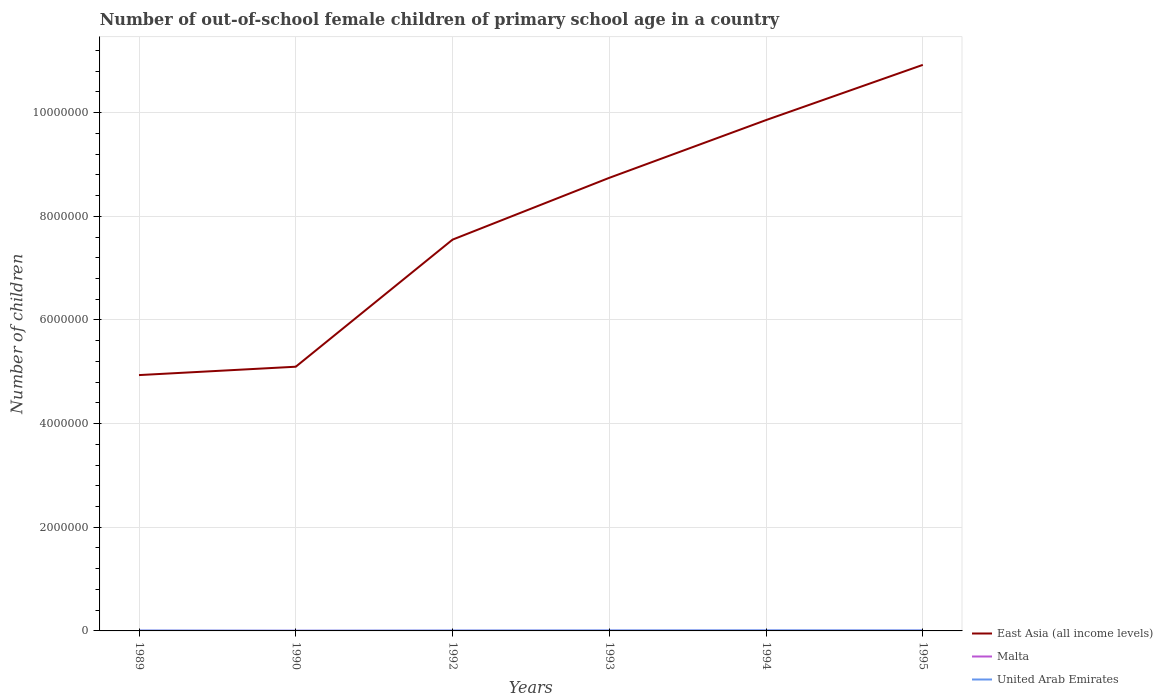Does the line corresponding to Malta intersect with the line corresponding to United Arab Emirates?
Keep it short and to the point. No. Across all years, what is the maximum number of out-of-school female children in Malta?
Provide a short and direct response. 2198. What is the total number of out-of-school female children in Malta in the graph?
Provide a short and direct response. -623. What is the difference between the highest and the second highest number of out-of-school female children in United Arab Emirates?
Give a very brief answer. 7538. What is the difference between the highest and the lowest number of out-of-school female children in United Arab Emirates?
Your answer should be very brief. 3. Is the number of out-of-school female children in East Asia (all income levels) strictly greater than the number of out-of-school female children in Malta over the years?
Provide a succinct answer. No. How many lines are there?
Keep it short and to the point. 3. What is the difference between two consecutive major ticks on the Y-axis?
Offer a terse response. 2.00e+06. Does the graph contain any zero values?
Offer a very short reply. No. Does the graph contain grids?
Keep it short and to the point. Yes. Where does the legend appear in the graph?
Provide a short and direct response. Bottom right. How many legend labels are there?
Your response must be concise. 3. How are the legend labels stacked?
Provide a succinct answer. Vertical. What is the title of the graph?
Ensure brevity in your answer.  Number of out-of-school female children of primary school age in a country. What is the label or title of the X-axis?
Your answer should be very brief. Years. What is the label or title of the Y-axis?
Make the answer very short. Number of children. What is the Number of children of East Asia (all income levels) in 1989?
Provide a succinct answer. 4.94e+06. What is the Number of children in Malta in 1989?
Provide a succinct answer. 2310. What is the Number of children of United Arab Emirates in 1989?
Provide a succinct answer. 7385. What is the Number of children of East Asia (all income levels) in 1990?
Ensure brevity in your answer.  5.10e+06. What is the Number of children in Malta in 1990?
Ensure brevity in your answer.  2198. What is the Number of children of United Arab Emirates in 1990?
Your answer should be very brief. 3562. What is the Number of children in East Asia (all income levels) in 1992?
Provide a short and direct response. 7.55e+06. What is the Number of children of Malta in 1992?
Keep it short and to the point. 2457. What is the Number of children of United Arab Emirates in 1992?
Ensure brevity in your answer.  7374. What is the Number of children in East Asia (all income levels) in 1993?
Offer a very short reply. 8.74e+06. What is the Number of children in Malta in 1993?
Provide a succinct answer. 2589. What is the Number of children in United Arab Emirates in 1993?
Offer a very short reply. 9490. What is the Number of children in East Asia (all income levels) in 1994?
Make the answer very short. 9.86e+06. What is the Number of children of Malta in 1994?
Give a very brief answer. 2933. What is the Number of children of United Arab Emirates in 1994?
Your response must be concise. 1.11e+04. What is the Number of children of East Asia (all income levels) in 1995?
Your response must be concise. 1.09e+07. What is the Number of children in Malta in 1995?
Provide a succinct answer. 3008. What is the Number of children in United Arab Emirates in 1995?
Give a very brief answer. 9912. Across all years, what is the maximum Number of children of East Asia (all income levels)?
Ensure brevity in your answer.  1.09e+07. Across all years, what is the maximum Number of children of Malta?
Your response must be concise. 3008. Across all years, what is the maximum Number of children in United Arab Emirates?
Offer a very short reply. 1.11e+04. Across all years, what is the minimum Number of children in East Asia (all income levels)?
Make the answer very short. 4.94e+06. Across all years, what is the minimum Number of children of Malta?
Make the answer very short. 2198. Across all years, what is the minimum Number of children of United Arab Emirates?
Give a very brief answer. 3562. What is the total Number of children in East Asia (all income levels) in the graph?
Your answer should be compact. 4.71e+07. What is the total Number of children in Malta in the graph?
Give a very brief answer. 1.55e+04. What is the total Number of children in United Arab Emirates in the graph?
Your answer should be very brief. 4.88e+04. What is the difference between the Number of children of East Asia (all income levels) in 1989 and that in 1990?
Provide a succinct answer. -1.61e+05. What is the difference between the Number of children of Malta in 1989 and that in 1990?
Give a very brief answer. 112. What is the difference between the Number of children in United Arab Emirates in 1989 and that in 1990?
Your answer should be very brief. 3823. What is the difference between the Number of children in East Asia (all income levels) in 1989 and that in 1992?
Offer a terse response. -2.61e+06. What is the difference between the Number of children in Malta in 1989 and that in 1992?
Give a very brief answer. -147. What is the difference between the Number of children of East Asia (all income levels) in 1989 and that in 1993?
Ensure brevity in your answer.  -3.81e+06. What is the difference between the Number of children in Malta in 1989 and that in 1993?
Your answer should be very brief. -279. What is the difference between the Number of children of United Arab Emirates in 1989 and that in 1993?
Offer a very short reply. -2105. What is the difference between the Number of children of East Asia (all income levels) in 1989 and that in 1994?
Provide a short and direct response. -4.92e+06. What is the difference between the Number of children in Malta in 1989 and that in 1994?
Ensure brevity in your answer.  -623. What is the difference between the Number of children of United Arab Emirates in 1989 and that in 1994?
Offer a very short reply. -3715. What is the difference between the Number of children in East Asia (all income levels) in 1989 and that in 1995?
Offer a terse response. -5.99e+06. What is the difference between the Number of children of Malta in 1989 and that in 1995?
Offer a terse response. -698. What is the difference between the Number of children in United Arab Emirates in 1989 and that in 1995?
Keep it short and to the point. -2527. What is the difference between the Number of children of East Asia (all income levels) in 1990 and that in 1992?
Offer a very short reply. -2.45e+06. What is the difference between the Number of children of Malta in 1990 and that in 1992?
Offer a very short reply. -259. What is the difference between the Number of children in United Arab Emirates in 1990 and that in 1992?
Your response must be concise. -3812. What is the difference between the Number of children of East Asia (all income levels) in 1990 and that in 1993?
Your answer should be compact. -3.64e+06. What is the difference between the Number of children of Malta in 1990 and that in 1993?
Ensure brevity in your answer.  -391. What is the difference between the Number of children in United Arab Emirates in 1990 and that in 1993?
Provide a succinct answer. -5928. What is the difference between the Number of children in East Asia (all income levels) in 1990 and that in 1994?
Provide a succinct answer. -4.76e+06. What is the difference between the Number of children in Malta in 1990 and that in 1994?
Your response must be concise. -735. What is the difference between the Number of children of United Arab Emirates in 1990 and that in 1994?
Keep it short and to the point. -7538. What is the difference between the Number of children in East Asia (all income levels) in 1990 and that in 1995?
Provide a succinct answer. -5.82e+06. What is the difference between the Number of children in Malta in 1990 and that in 1995?
Give a very brief answer. -810. What is the difference between the Number of children of United Arab Emirates in 1990 and that in 1995?
Offer a terse response. -6350. What is the difference between the Number of children of East Asia (all income levels) in 1992 and that in 1993?
Offer a terse response. -1.19e+06. What is the difference between the Number of children in Malta in 1992 and that in 1993?
Your answer should be very brief. -132. What is the difference between the Number of children of United Arab Emirates in 1992 and that in 1993?
Ensure brevity in your answer.  -2116. What is the difference between the Number of children in East Asia (all income levels) in 1992 and that in 1994?
Offer a terse response. -2.31e+06. What is the difference between the Number of children of Malta in 1992 and that in 1994?
Your answer should be compact. -476. What is the difference between the Number of children of United Arab Emirates in 1992 and that in 1994?
Give a very brief answer. -3726. What is the difference between the Number of children of East Asia (all income levels) in 1992 and that in 1995?
Offer a terse response. -3.37e+06. What is the difference between the Number of children in Malta in 1992 and that in 1995?
Your answer should be very brief. -551. What is the difference between the Number of children in United Arab Emirates in 1992 and that in 1995?
Offer a very short reply. -2538. What is the difference between the Number of children of East Asia (all income levels) in 1993 and that in 1994?
Offer a very short reply. -1.11e+06. What is the difference between the Number of children of Malta in 1993 and that in 1994?
Your answer should be very brief. -344. What is the difference between the Number of children of United Arab Emirates in 1993 and that in 1994?
Make the answer very short. -1610. What is the difference between the Number of children in East Asia (all income levels) in 1993 and that in 1995?
Ensure brevity in your answer.  -2.18e+06. What is the difference between the Number of children in Malta in 1993 and that in 1995?
Provide a short and direct response. -419. What is the difference between the Number of children of United Arab Emirates in 1993 and that in 1995?
Ensure brevity in your answer.  -422. What is the difference between the Number of children in East Asia (all income levels) in 1994 and that in 1995?
Your response must be concise. -1.07e+06. What is the difference between the Number of children of Malta in 1994 and that in 1995?
Provide a short and direct response. -75. What is the difference between the Number of children of United Arab Emirates in 1994 and that in 1995?
Ensure brevity in your answer.  1188. What is the difference between the Number of children in East Asia (all income levels) in 1989 and the Number of children in Malta in 1990?
Your answer should be compact. 4.93e+06. What is the difference between the Number of children in East Asia (all income levels) in 1989 and the Number of children in United Arab Emirates in 1990?
Your answer should be compact. 4.93e+06. What is the difference between the Number of children of Malta in 1989 and the Number of children of United Arab Emirates in 1990?
Ensure brevity in your answer.  -1252. What is the difference between the Number of children of East Asia (all income levels) in 1989 and the Number of children of Malta in 1992?
Give a very brief answer. 4.93e+06. What is the difference between the Number of children in East Asia (all income levels) in 1989 and the Number of children in United Arab Emirates in 1992?
Your answer should be compact. 4.93e+06. What is the difference between the Number of children in Malta in 1989 and the Number of children in United Arab Emirates in 1992?
Your response must be concise. -5064. What is the difference between the Number of children in East Asia (all income levels) in 1989 and the Number of children in Malta in 1993?
Your response must be concise. 4.93e+06. What is the difference between the Number of children in East Asia (all income levels) in 1989 and the Number of children in United Arab Emirates in 1993?
Keep it short and to the point. 4.93e+06. What is the difference between the Number of children of Malta in 1989 and the Number of children of United Arab Emirates in 1993?
Offer a very short reply. -7180. What is the difference between the Number of children of East Asia (all income levels) in 1989 and the Number of children of Malta in 1994?
Keep it short and to the point. 4.93e+06. What is the difference between the Number of children in East Asia (all income levels) in 1989 and the Number of children in United Arab Emirates in 1994?
Keep it short and to the point. 4.93e+06. What is the difference between the Number of children in Malta in 1989 and the Number of children in United Arab Emirates in 1994?
Keep it short and to the point. -8790. What is the difference between the Number of children in East Asia (all income levels) in 1989 and the Number of children in Malta in 1995?
Offer a terse response. 4.93e+06. What is the difference between the Number of children of East Asia (all income levels) in 1989 and the Number of children of United Arab Emirates in 1995?
Your answer should be very brief. 4.93e+06. What is the difference between the Number of children of Malta in 1989 and the Number of children of United Arab Emirates in 1995?
Ensure brevity in your answer.  -7602. What is the difference between the Number of children in East Asia (all income levels) in 1990 and the Number of children in Malta in 1992?
Keep it short and to the point. 5.10e+06. What is the difference between the Number of children in East Asia (all income levels) in 1990 and the Number of children in United Arab Emirates in 1992?
Your answer should be compact. 5.09e+06. What is the difference between the Number of children in Malta in 1990 and the Number of children in United Arab Emirates in 1992?
Give a very brief answer. -5176. What is the difference between the Number of children in East Asia (all income levels) in 1990 and the Number of children in Malta in 1993?
Your response must be concise. 5.10e+06. What is the difference between the Number of children in East Asia (all income levels) in 1990 and the Number of children in United Arab Emirates in 1993?
Give a very brief answer. 5.09e+06. What is the difference between the Number of children in Malta in 1990 and the Number of children in United Arab Emirates in 1993?
Give a very brief answer. -7292. What is the difference between the Number of children of East Asia (all income levels) in 1990 and the Number of children of Malta in 1994?
Give a very brief answer. 5.09e+06. What is the difference between the Number of children of East Asia (all income levels) in 1990 and the Number of children of United Arab Emirates in 1994?
Offer a very short reply. 5.09e+06. What is the difference between the Number of children of Malta in 1990 and the Number of children of United Arab Emirates in 1994?
Give a very brief answer. -8902. What is the difference between the Number of children in East Asia (all income levels) in 1990 and the Number of children in Malta in 1995?
Offer a terse response. 5.09e+06. What is the difference between the Number of children of East Asia (all income levels) in 1990 and the Number of children of United Arab Emirates in 1995?
Provide a short and direct response. 5.09e+06. What is the difference between the Number of children in Malta in 1990 and the Number of children in United Arab Emirates in 1995?
Give a very brief answer. -7714. What is the difference between the Number of children in East Asia (all income levels) in 1992 and the Number of children in Malta in 1993?
Make the answer very short. 7.55e+06. What is the difference between the Number of children of East Asia (all income levels) in 1992 and the Number of children of United Arab Emirates in 1993?
Give a very brief answer. 7.54e+06. What is the difference between the Number of children of Malta in 1992 and the Number of children of United Arab Emirates in 1993?
Offer a very short reply. -7033. What is the difference between the Number of children of East Asia (all income levels) in 1992 and the Number of children of Malta in 1994?
Your response must be concise. 7.55e+06. What is the difference between the Number of children of East Asia (all income levels) in 1992 and the Number of children of United Arab Emirates in 1994?
Offer a very short reply. 7.54e+06. What is the difference between the Number of children in Malta in 1992 and the Number of children in United Arab Emirates in 1994?
Offer a terse response. -8643. What is the difference between the Number of children of East Asia (all income levels) in 1992 and the Number of children of Malta in 1995?
Provide a succinct answer. 7.55e+06. What is the difference between the Number of children in East Asia (all income levels) in 1992 and the Number of children in United Arab Emirates in 1995?
Give a very brief answer. 7.54e+06. What is the difference between the Number of children in Malta in 1992 and the Number of children in United Arab Emirates in 1995?
Make the answer very short. -7455. What is the difference between the Number of children of East Asia (all income levels) in 1993 and the Number of children of Malta in 1994?
Your response must be concise. 8.74e+06. What is the difference between the Number of children of East Asia (all income levels) in 1993 and the Number of children of United Arab Emirates in 1994?
Offer a very short reply. 8.73e+06. What is the difference between the Number of children in Malta in 1993 and the Number of children in United Arab Emirates in 1994?
Provide a short and direct response. -8511. What is the difference between the Number of children of East Asia (all income levels) in 1993 and the Number of children of Malta in 1995?
Keep it short and to the point. 8.74e+06. What is the difference between the Number of children in East Asia (all income levels) in 1993 and the Number of children in United Arab Emirates in 1995?
Keep it short and to the point. 8.73e+06. What is the difference between the Number of children in Malta in 1993 and the Number of children in United Arab Emirates in 1995?
Your response must be concise. -7323. What is the difference between the Number of children in East Asia (all income levels) in 1994 and the Number of children in Malta in 1995?
Offer a terse response. 9.85e+06. What is the difference between the Number of children in East Asia (all income levels) in 1994 and the Number of children in United Arab Emirates in 1995?
Provide a succinct answer. 9.85e+06. What is the difference between the Number of children in Malta in 1994 and the Number of children in United Arab Emirates in 1995?
Offer a terse response. -6979. What is the average Number of children of East Asia (all income levels) per year?
Your answer should be very brief. 7.85e+06. What is the average Number of children of Malta per year?
Ensure brevity in your answer.  2582.5. What is the average Number of children of United Arab Emirates per year?
Offer a very short reply. 8137.17. In the year 1989, what is the difference between the Number of children of East Asia (all income levels) and Number of children of Malta?
Your answer should be compact. 4.93e+06. In the year 1989, what is the difference between the Number of children in East Asia (all income levels) and Number of children in United Arab Emirates?
Offer a very short reply. 4.93e+06. In the year 1989, what is the difference between the Number of children of Malta and Number of children of United Arab Emirates?
Keep it short and to the point. -5075. In the year 1990, what is the difference between the Number of children in East Asia (all income levels) and Number of children in Malta?
Offer a very short reply. 5.10e+06. In the year 1990, what is the difference between the Number of children of East Asia (all income levels) and Number of children of United Arab Emirates?
Make the answer very short. 5.09e+06. In the year 1990, what is the difference between the Number of children in Malta and Number of children in United Arab Emirates?
Keep it short and to the point. -1364. In the year 1992, what is the difference between the Number of children in East Asia (all income levels) and Number of children in Malta?
Your answer should be very brief. 7.55e+06. In the year 1992, what is the difference between the Number of children in East Asia (all income levels) and Number of children in United Arab Emirates?
Give a very brief answer. 7.54e+06. In the year 1992, what is the difference between the Number of children in Malta and Number of children in United Arab Emirates?
Your answer should be compact. -4917. In the year 1993, what is the difference between the Number of children in East Asia (all income levels) and Number of children in Malta?
Your answer should be compact. 8.74e+06. In the year 1993, what is the difference between the Number of children of East Asia (all income levels) and Number of children of United Arab Emirates?
Give a very brief answer. 8.73e+06. In the year 1993, what is the difference between the Number of children of Malta and Number of children of United Arab Emirates?
Your response must be concise. -6901. In the year 1994, what is the difference between the Number of children of East Asia (all income levels) and Number of children of Malta?
Make the answer very short. 9.85e+06. In the year 1994, what is the difference between the Number of children in East Asia (all income levels) and Number of children in United Arab Emirates?
Provide a short and direct response. 9.85e+06. In the year 1994, what is the difference between the Number of children of Malta and Number of children of United Arab Emirates?
Offer a very short reply. -8167. In the year 1995, what is the difference between the Number of children in East Asia (all income levels) and Number of children in Malta?
Provide a succinct answer. 1.09e+07. In the year 1995, what is the difference between the Number of children in East Asia (all income levels) and Number of children in United Arab Emirates?
Your response must be concise. 1.09e+07. In the year 1995, what is the difference between the Number of children in Malta and Number of children in United Arab Emirates?
Make the answer very short. -6904. What is the ratio of the Number of children of East Asia (all income levels) in 1989 to that in 1990?
Offer a terse response. 0.97. What is the ratio of the Number of children of Malta in 1989 to that in 1990?
Keep it short and to the point. 1.05. What is the ratio of the Number of children in United Arab Emirates in 1989 to that in 1990?
Offer a terse response. 2.07. What is the ratio of the Number of children of East Asia (all income levels) in 1989 to that in 1992?
Keep it short and to the point. 0.65. What is the ratio of the Number of children in Malta in 1989 to that in 1992?
Keep it short and to the point. 0.94. What is the ratio of the Number of children in East Asia (all income levels) in 1989 to that in 1993?
Keep it short and to the point. 0.56. What is the ratio of the Number of children in Malta in 1989 to that in 1993?
Offer a very short reply. 0.89. What is the ratio of the Number of children in United Arab Emirates in 1989 to that in 1993?
Provide a short and direct response. 0.78. What is the ratio of the Number of children of East Asia (all income levels) in 1989 to that in 1994?
Your answer should be very brief. 0.5. What is the ratio of the Number of children of Malta in 1989 to that in 1994?
Your answer should be compact. 0.79. What is the ratio of the Number of children in United Arab Emirates in 1989 to that in 1994?
Provide a succinct answer. 0.67. What is the ratio of the Number of children of East Asia (all income levels) in 1989 to that in 1995?
Offer a terse response. 0.45. What is the ratio of the Number of children of Malta in 1989 to that in 1995?
Offer a terse response. 0.77. What is the ratio of the Number of children in United Arab Emirates in 1989 to that in 1995?
Provide a succinct answer. 0.75. What is the ratio of the Number of children of East Asia (all income levels) in 1990 to that in 1992?
Your response must be concise. 0.68. What is the ratio of the Number of children in Malta in 1990 to that in 1992?
Offer a very short reply. 0.89. What is the ratio of the Number of children of United Arab Emirates in 1990 to that in 1992?
Your answer should be very brief. 0.48. What is the ratio of the Number of children in East Asia (all income levels) in 1990 to that in 1993?
Ensure brevity in your answer.  0.58. What is the ratio of the Number of children of Malta in 1990 to that in 1993?
Ensure brevity in your answer.  0.85. What is the ratio of the Number of children of United Arab Emirates in 1990 to that in 1993?
Offer a terse response. 0.38. What is the ratio of the Number of children of East Asia (all income levels) in 1990 to that in 1994?
Your response must be concise. 0.52. What is the ratio of the Number of children of Malta in 1990 to that in 1994?
Give a very brief answer. 0.75. What is the ratio of the Number of children of United Arab Emirates in 1990 to that in 1994?
Make the answer very short. 0.32. What is the ratio of the Number of children in East Asia (all income levels) in 1990 to that in 1995?
Make the answer very short. 0.47. What is the ratio of the Number of children in Malta in 1990 to that in 1995?
Give a very brief answer. 0.73. What is the ratio of the Number of children in United Arab Emirates in 1990 to that in 1995?
Your response must be concise. 0.36. What is the ratio of the Number of children of East Asia (all income levels) in 1992 to that in 1993?
Your response must be concise. 0.86. What is the ratio of the Number of children in Malta in 1992 to that in 1993?
Give a very brief answer. 0.95. What is the ratio of the Number of children in United Arab Emirates in 1992 to that in 1993?
Provide a short and direct response. 0.78. What is the ratio of the Number of children of East Asia (all income levels) in 1992 to that in 1994?
Give a very brief answer. 0.77. What is the ratio of the Number of children in Malta in 1992 to that in 1994?
Keep it short and to the point. 0.84. What is the ratio of the Number of children in United Arab Emirates in 1992 to that in 1994?
Ensure brevity in your answer.  0.66. What is the ratio of the Number of children of East Asia (all income levels) in 1992 to that in 1995?
Provide a short and direct response. 0.69. What is the ratio of the Number of children in Malta in 1992 to that in 1995?
Ensure brevity in your answer.  0.82. What is the ratio of the Number of children in United Arab Emirates in 1992 to that in 1995?
Make the answer very short. 0.74. What is the ratio of the Number of children in East Asia (all income levels) in 1993 to that in 1994?
Provide a short and direct response. 0.89. What is the ratio of the Number of children in Malta in 1993 to that in 1994?
Make the answer very short. 0.88. What is the ratio of the Number of children in United Arab Emirates in 1993 to that in 1994?
Your answer should be very brief. 0.85. What is the ratio of the Number of children in East Asia (all income levels) in 1993 to that in 1995?
Your answer should be very brief. 0.8. What is the ratio of the Number of children in Malta in 1993 to that in 1995?
Provide a short and direct response. 0.86. What is the ratio of the Number of children in United Arab Emirates in 1993 to that in 1995?
Offer a terse response. 0.96. What is the ratio of the Number of children in East Asia (all income levels) in 1994 to that in 1995?
Give a very brief answer. 0.9. What is the ratio of the Number of children in Malta in 1994 to that in 1995?
Keep it short and to the point. 0.98. What is the ratio of the Number of children of United Arab Emirates in 1994 to that in 1995?
Offer a terse response. 1.12. What is the difference between the highest and the second highest Number of children in East Asia (all income levels)?
Ensure brevity in your answer.  1.07e+06. What is the difference between the highest and the second highest Number of children of Malta?
Make the answer very short. 75. What is the difference between the highest and the second highest Number of children of United Arab Emirates?
Your answer should be very brief. 1188. What is the difference between the highest and the lowest Number of children in East Asia (all income levels)?
Offer a terse response. 5.99e+06. What is the difference between the highest and the lowest Number of children in Malta?
Provide a short and direct response. 810. What is the difference between the highest and the lowest Number of children in United Arab Emirates?
Your answer should be very brief. 7538. 